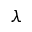Convert formula to latex. <formula><loc_0><loc_0><loc_500><loc_500>\lambda</formula> 